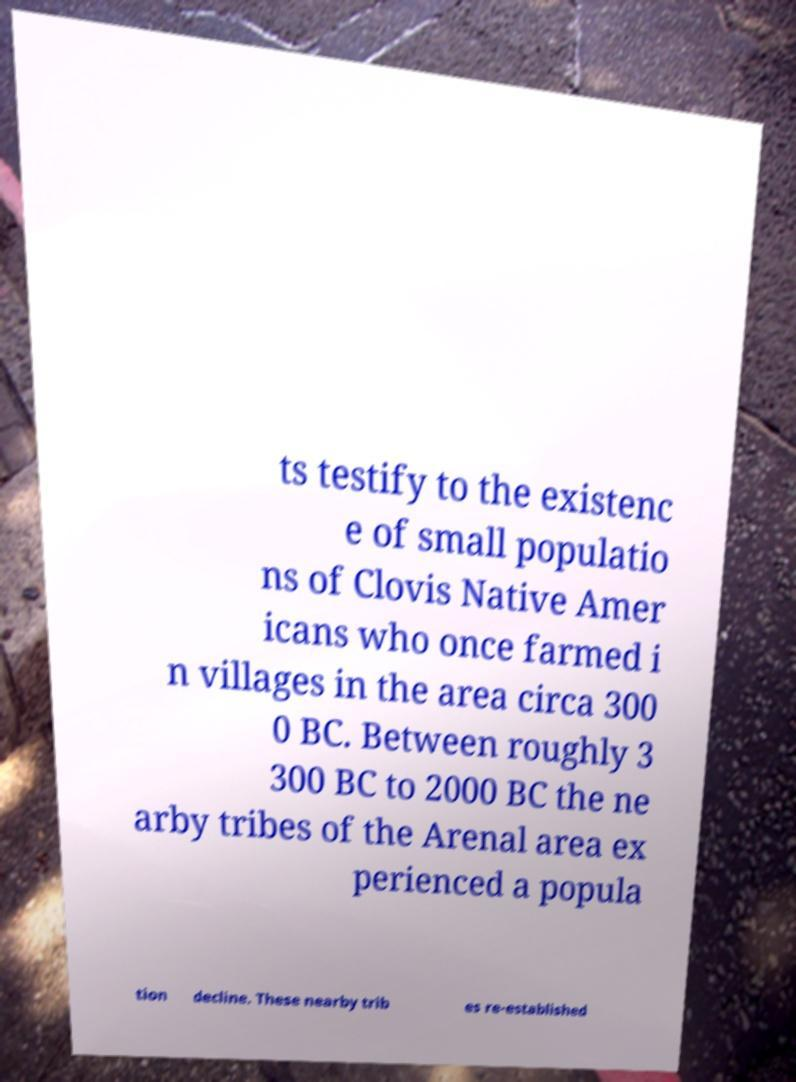There's text embedded in this image that I need extracted. Can you transcribe it verbatim? ts testify to the existenc e of small populatio ns of Clovis Native Amer icans who once farmed i n villages in the area circa 300 0 BC. Between roughly 3 300 BC to 2000 BC the ne arby tribes of the Arenal area ex perienced a popula tion decline. These nearby trib es re-established 